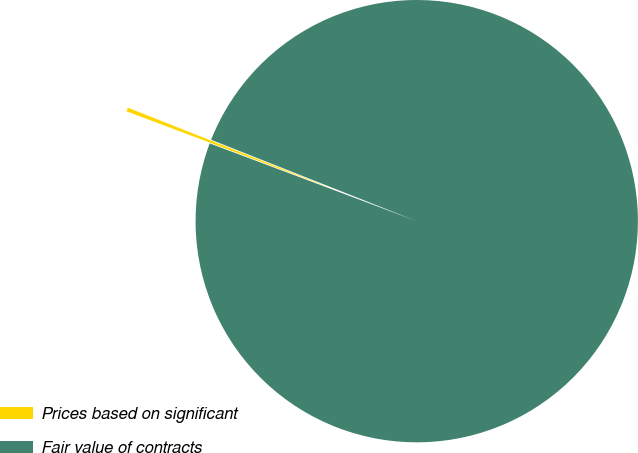Convert chart to OTSL. <chart><loc_0><loc_0><loc_500><loc_500><pie_chart><fcel>Prices based on significant<fcel>Fair value of contracts<nl><fcel>0.28%<fcel>99.72%<nl></chart> 